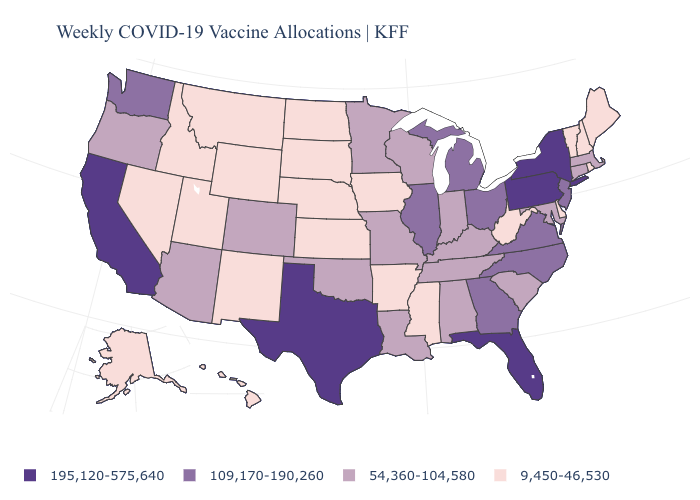Among the states that border North Dakota , which have the lowest value?
Write a very short answer. Montana, South Dakota. What is the value of Louisiana?
Be succinct. 54,360-104,580. Does Texas have a lower value than North Dakota?
Concise answer only. No. What is the value of Montana?
Short answer required. 9,450-46,530. What is the value of North Dakota?
Concise answer only. 9,450-46,530. How many symbols are there in the legend?
Be succinct. 4. How many symbols are there in the legend?
Quick response, please. 4. Does New Hampshire have the highest value in the USA?
Keep it brief. No. Is the legend a continuous bar?
Be succinct. No. Does Michigan have a lower value than Vermont?
Short answer required. No. What is the highest value in the USA?
Concise answer only. 195,120-575,640. Among the states that border Kansas , which have the lowest value?
Short answer required. Nebraska. What is the value of Florida?
Write a very short answer. 195,120-575,640. What is the highest value in states that border West Virginia?
Be succinct. 195,120-575,640. What is the value of Michigan?
Be succinct. 109,170-190,260. 